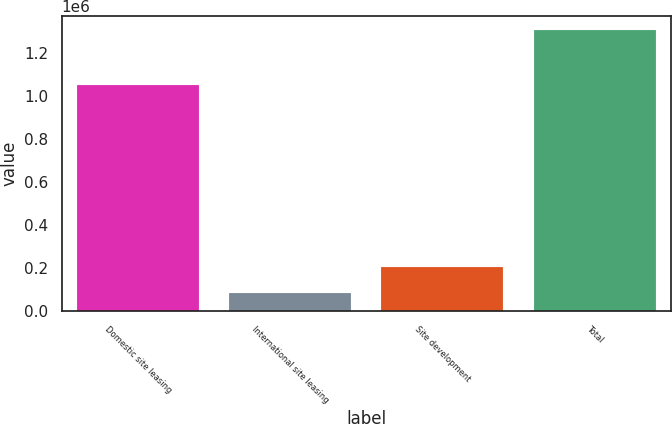Convert chart to OTSL. <chart><loc_0><loc_0><loc_500><loc_500><bar_chart><fcel>Domestic site leasing<fcel>International site leasing<fcel>Site development<fcel>Total<nl><fcel>1.04876e+06<fcel>84257<fcel>206318<fcel>1.30487e+06<nl></chart> 